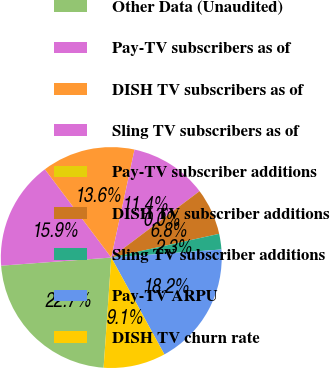<chart> <loc_0><loc_0><loc_500><loc_500><pie_chart><fcel>Other Data (Unaudited)<fcel>Pay-TV subscribers as of<fcel>DISH TV subscribers as of<fcel>Sling TV subscribers as of<fcel>Pay-TV subscriber additions<fcel>DISH TV subscriber additions<fcel>Sling TV subscriber additions<fcel>Pay-TV ARPU<fcel>DISH TV churn rate<nl><fcel>22.72%<fcel>15.91%<fcel>13.64%<fcel>11.36%<fcel>0.0%<fcel>6.82%<fcel>2.28%<fcel>18.18%<fcel>9.09%<nl></chart> 